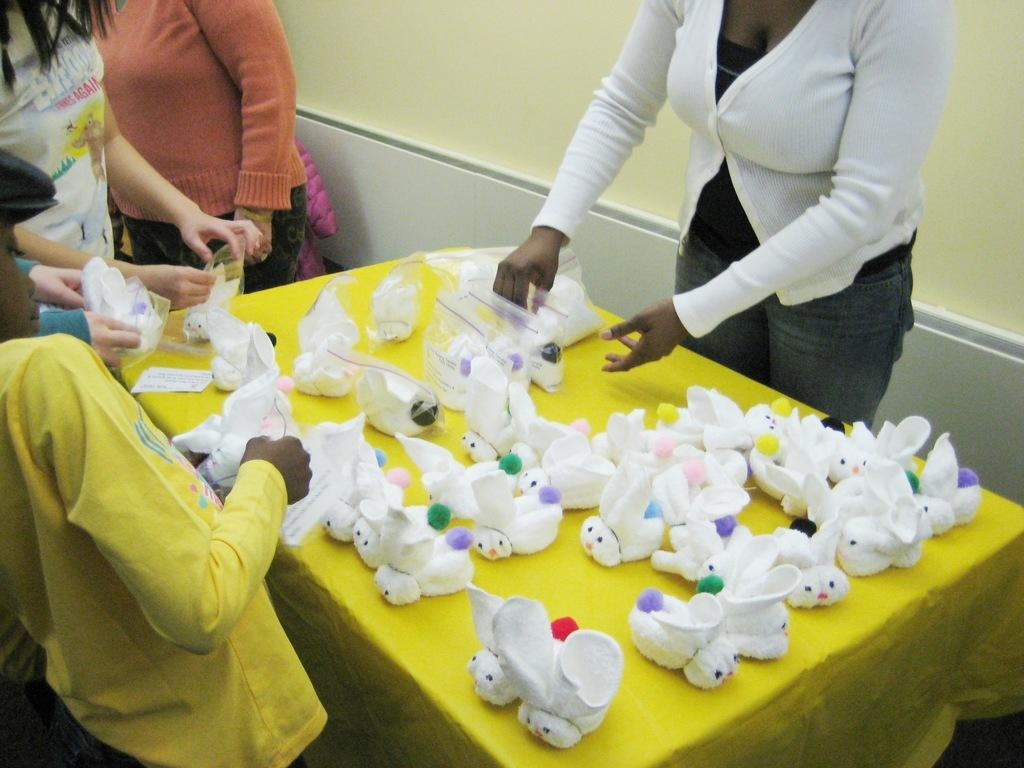Who is present in the image? There are people in the image. What are the people doing in the image? The people are standing and packing dolls in packets. What can be seen in the background of the image? There is a wall in the background of the image. What type of curtain is hanging on the wall in the image? There is no curtain present in the image; only a wall is visible in the background. 